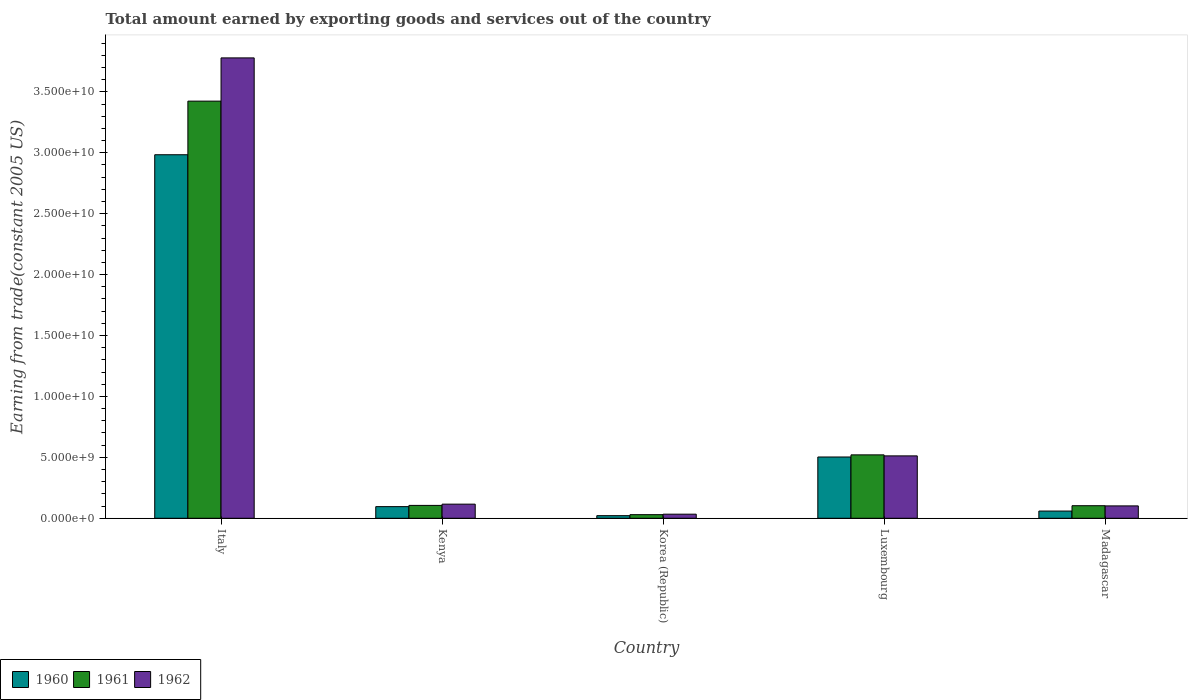How many different coloured bars are there?
Provide a succinct answer. 3. How many groups of bars are there?
Ensure brevity in your answer.  5. How many bars are there on the 3rd tick from the left?
Provide a short and direct response. 3. How many bars are there on the 4th tick from the right?
Your answer should be very brief. 3. What is the label of the 3rd group of bars from the left?
Your response must be concise. Korea (Republic). What is the total amount earned by exporting goods and services in 1962 in Kenya?
Your response must be concise. 1.16e+09. Across all countries, what is the maximum total amount earned by exporting goods and services in 1962?
Provide a succinct answer. 3.78e+1. Across all countries, what is the minimum total amount earned by exporting goods and services in 1962?
Offer a terse response. 3.35e+08. What is the total total amount earned by exporting goods and services in 1962 in the graph?
Your answer should be compact. 4.54e+1. What is the difference between the total amount earned by exporting goods and services in 1961 in Italy and that in Luxembourg?
Your response must be concise. 2.90e+1. What is the difference between the total amount earned by exporting goods and services in 1960 in Madagascar and the total amount earned by exporting goods and services in 1961 in Korea (Republic)?
Provide a succinct answer. 2.95e+08. What is the average total amount earned by exporting goods and services in 1961 per country?
Ensure brevity in your answer.  8.37e+09. What is the difference between the total amount earned by exporting goods and services of/in 1962 and total amount earned by exporting goods and services of/in 1960 in Kenya?
Keep it short and to the point. 2.04e+08. In how many countries, is the total amount earned by exporting goods and services in 1962 greater than 25000000000 US$?
Offer a very short reply. 1. What is the ratio of the total amount earned by exporting goods and services in 1962 in Italy to that in Madagascar?
Offer a very short reply. 37.22. What is the difference between the highest and the second highest total amount earned by exporting goods and services in 1962?
Give a very brief answer. 3.66e+1. What is the difference between the highest and the lowest total amount earned by exporting goods and services in 1962?
Offer a very short reply. 3.75e+1. Is the sum of the total amount earned by exporting goods and services in 1962 in Korea (Republic) and Luxembourg greater than the maximum total amount earned by exporting goods and services in 1960 across all countries?
Your response must be concise. No. What does the 1st bar from the right in Italy represents?
Your answer should be very brief. 1962. Is it the case that in every country, the sum of the total amount earned by exporting goods and services in 1960 and total amount earned by exporting goods and services in 1961 is greater than the total amount earned by exporting goods and services in 1962?
Ensure brevity in your answer.  Yes. Are all the bars in the graph horizontal?
Make the answer very short. No. How many countries are there in the graph?
Give a very brief answer. 5. Does the graph contain any zero values?
Your response must be concise. No. Where does the legend appear in the graph?
Offer a terse response. Bottom left. How many legend labels are there?
Provide a succinct answer. 3. How are the legend labels stacked?
Ensure brevity in your answer.  Horizontal. What is the title of the graph?
Give a very brief answer. Total amount earned by exporting goods and services out of the country. What is the label or title of the X-axis?
Offer a very short reply. Country. What is the label or title of the Y-axis?
Your answer should be very brief. Earning from trade(constant 2005 US). What is the Earning from trade(constant 2005 US) in 1960 in Italy?
Your answer should be compact. 2.98e+1. What is the Earning from trade(constant 2005 US) in 1961 in Italy?
Offer a very short reply. 3.42e+1. What is the Earning from trade(constant 2005 US) of 1962 in Italy?
Your answer should be very brief. 3.78e+1. What is the Earning from trade(constant 2005 US) of 1960 in Kenya?
Give a very brief answer. 9.56e+08. What is the Earning from trade(constant 2005 US) in 1961 in Kenya?
Your answer should be compact. 1.06e+09. What is the Earning from trade(constant 2005 US) in 1962 in Kenya?
Your answer should be compact. 1.16e+09. What is the Earning from trade(constant 2005 US) in 1960 in Korea (Republic)?
Your response must be concise. 2.14e+08. What is the Earning from trade(constant 2005 US) of 1961 in Korea (Republic)?
Keep it short and to the point. 2.96e+08. What is the Earning from trade(constant 2005 US) of 1962 in Korea (Republic)?
Make the answer very short. 3.35e+08. What is the Earning from trade(constant 2005 US) of 1960 in Luxembourg?
Your answer should be compact. 5.03e+09. What is the Earning from trade(constant 2005 US) in 1961 in Luxembourg?
Make the answer very short. 5.20e+09. What is the Earning from trade(constant 2005 US) of 1962 in Luxembourg?
Offer a very short reply. 5.12e+09. What is the Earning from trade(constant 2005 US) in 1960 in Madagascar?
Your answer should be compact. 5.92e+08. What is the Earning from trade(constant 2005 US) in 1961 in Madagascar?
Provide a succinct answer. 1.03e+09. What is the Earning from trade(constant 2005 US) of 1962 in Madagascar?
Provide a succinct answer. 1.02e+09. Across all countries, what is the maximum Earning from trade(constant 2005 US) of 1960?
Give a very brief answer. 2.98e+1. Across all countries, what is the maximum Earning from trade(constant 2005 US) of 1961?
Your response must be concise. 3.42e+1. Across all countries, what is the maximum Earning from trade(constant 2005 US) in 1962?
Keep it short and to the point. 3.78e+1. Across all countries, what is the minimum Earning from trade(constant 2005 US) of 1960?
Make the answer very short. 2.14e+08. Across all countries, what is the minimum Earning from trade(constant 2005 US) of 1961?
Offer a very short reply. 2.96e+08. Across all countries, what is the minimum Earning from trade(constant 2005 US) in 1962?
Offer a very short reply. 3.35e+08. What is the total Earning from trade(constant 2005 US) in 1960 in the graph?
Ensure brevity in your answer.  3.66e+1. What is the total Earning from trade(constant 2005 US) of 1961 in the graph?
Offer a terse response. 4.18e+1. What is the total Earning from trade(constant 2005 US) of 1962 in the graph?
Your response must be concise. 4.54e+1. What is the difference between the Earning from trade(constant 2005 US) of 1960 in Italy and that in Kenya?
Your answer should be very brief. 2.89e+1. What is the difference between the Earning from trade(constant 2005 US) in 1961 in Italy and that in Kenya?
Provide a short and direct response. 3.32e+1. What is the difference between the Earning from trade(constant 2005 US) in 1962 in Italy and that in Kenya?
Give a very brief answer. 3.66e+1. What is the difference between the Earning from trade(constant 2005 US) in 1960 in Italy and that in Korea (Republic)?
Your answer should be compact. 2.96e+1. What is the difference between the Earning from trade(constant 2005 US) of 1961 in Italy and that in Korea (Republic)?
Offer a very short reply. 3.39e+1. What is the difference between the Earning from trade(constant 2005 US) of 1962 in Italy and that in Korea (Republic)?
Your answer should be compact. 3.75e+1. What is the difference between the Earning from trade(constant 2005 US) of 1960 in Italy and that in Luxembourg?
Offer a very short reply. 2.48e+1. What is the difference between the Earning from trade(constant 2005 US) in 1961 in Italy and that in Luxembourg?
Your response must be concise. 2.90e+1. What is the difference between the Earning from trade(constant 2005 US) in 1962 in Italy and that in Luxembourg?
Provide a short and direct response. 3.27e+1. What is the difference between the Earning from trade(constant 2005 US) of 1960 in Italy and that in Madagascar?
Your answer should be very brief. 2.92e+1. What is the difference between the Earning from trade(constant 2005 US) of 1961 in Italy and that in Madagascar?
Offer a terse response. 3.32e+1. What is the difference between the Earning from trade(constant 2005 US) in 1962 in Italy and that in Madagascar?
Your answer should be very brief. 3.68e+1. What is the difference between the Earning from trade(constant 2005 US) in 1960 in Kenya and that in Korea (Republic)?
Give a very brief answer. 7.42e+08. What is the difference between the Earning from trade(constant 2005 US) of 1961 in Kenya and that in Korea (Republic)?
Give a very brief answer. 7.60e+08. What is the difference between the Earning from trade(constant 2005 US) in 1962 in Kenya and that in Korea (Republic)?
Your answer should be compact. 8.24e+08. What is the difference between the Earning from trade(constant 2005 US) in 1960 in Kenya and that in Luxembourg?
Provide a short and direct response. -4.07e+09. What is the difference between the Earning from trade(constant 2005 US) in 1961 in Kenya and that in Luxembourg?
Make the answer very short. -4.15e+09. What is the difference between the Earning from trade(constant 2005 US) of 1962 in Kenya and that in Luxembourg?
Offer a very short reply. -3.96e+09. What is the difference between the Earning from trade(constant 2005 US) in 1960 in Kenya and that in Madagascar?
Make the answer very short. 3.64e+08. What is the difference between the Earning from trade(constant 2005 US) in 1961 in Kenya and that in Madagascar?
Offer a terse response. 2.53e+07. What is the difference between the Earning from trade(constant 2005 US) of 1962 in Kenya and that in Madagascar?
Offer a terse response. 1.44e+08. What is the difference between the Earning from trade(constant 2005 US) of 1960 in Korea (Republic) and that in Luxembourg?
Give a very brief answer. -4.81e+09. What is the difference between the Earning from trade(constant 2005 US) of 1961 in Korea (Republic) and that in Luxembourg?
Your response must be concise. -4.91e+09. What is the difference between the Earning from trade(constant 2005 US) in 1962 in Korea (Republic) and that in Luxembourg?
Make the answer very short. -4.79e+09. What is the difference between the Earning from trade(constant 2005 US) of 1960 in Korea (Republic) and that in Madagascar?
Offer a terse response. -3.78e+08. What is the difference between the Earning from trade(constant 2005 US) in 1961 in Korea (Republic) and that in Madagascar?
Provide a short and direct response. -7.35e+08. What is the difference between the Earning from trade(constant 2005 US) in 1962 in Korea (Republic) and that in Madagascar?
Provide a short and direct response. -6.80e+08. What is the difference between the Earning from trade(constant 2005 US) of 1960 in Luxembourg and that in Madagascar?
Your response must be concise. 4.44e+09. What is the difference between the Earning from trade(constant 2005 US) of 1961 in Luxembourg and that in Madagascar?
Your answer should be very brief. 4.17e+09. What is the difference between the Earning from trade(constant 2005 US) of 1962 in Luxembourg and that in Madagascar?
Your answer should be very brief. 4.11e+09. What is the difference between the Earning from trade(constant 2005 US) of 1960 in Italy and the Earning from trade(constant 2005 US) of 1961 in Kenya?
Keep it short and to the point. 2.88e+1. What is the difference between the Earning from trade(constant 2005 US) of 1960 in Italy and the Earning from trade(constant 2005 US) of 1962 in Kenya?
Make the answer very short. 2.87e+1. What is the difference between the Earning from trade(constant 2005 US) of 1961 in Italy and the Earning from trade(constant 2005 US) of 1962 in Kenya?
Give a very brief answer. 3.31e+1. What is the difference between the Earning from trade(constant 2005 US) in 1960 in Italy and the Earning from trade(constant 2005 US) in 1961 in Korea (Republic)?
Your response must be concise. 2.95e+1. What is the difference between the Earning from trade(constant 2005 US) in 1960 in Italy and the Earning from trade(constant 2005 US) in 1962 in Korea (Republic)?
Provide a succinct answer. 2.95e+1. What is the difference between the Earning from trade(constant 2005 US) of 1961 in Italy and the Earning from trade(constant 2005 US) of 1962 in Korea (Republic)?
Make the answer very short. 3.39e+1. What is the difference between the Earning from trade(constant 2005 US) in 1960 in Italy and the Earning from trade(constant 2005 US) in 1961 in Luxembourg?
Make the answer very short. 2.46e+1. What is the difference between the Earning from trade(constant 2005 US) in 1960 in Italy and the Earning from trade(constant 2005 US) in 1962 in Luxembourg?
Offer a very short reply. 2.47e+1. What is the difference between the Earning from trade(constant 2005 US) in 1961 in Italy and the Earning from trade(constant 2005 US) in 1962 in Luxembourg?
Give a very brief answer. 2.91e+1. What is the difference between the Earning from trade(constant 2005 US) in 1960 in Italy and the Earning from trade(constant 2005 US) in 1961 in Madagascar?
Offer a very short reply. 2.88e+1. What is the difference between the Earning from trade(constant 2005 US) in 1960 in Italy and the Earning from trade(constant 2005 US) in 1962 in Madagascar?
Offer a terse response. 2.88e+1. What is the difference between the Earning from trade(constant 2005 US) in 1961 in Italy and the Earning from trade(constant 2005 US) in 1962 in Madagascar?
Make the answer very short. 3.32e+1. What is the difference between the Earning from trade(constant 2005 US) of 1960 in Kenya and the Earning from trade(constant 2005 US) of 1961 in Korea (Republic)?
Provide a short and direct response. 6.59e+08. What is the difference between the Earning from trade(constant 2005 US) in 1960 in Kenya and the Earning from trade(constant 2005 US) in 1962 in Korea (Republic)?
Provide a succinct answer. 6.21e+08. What is the difference between the Earning from trade(constant 2005 US) in 1961 in Kenya and the Earning from trade(constant 2005 US) in 1962 in Korea (Republic)?
Offer a terse response. 7.21e+08. What is the difference between the Earning from trade(constant 2005 US) in 1960 in Kenya and the Earning from trade(constant 2005 US) in 1961 in Luxembourg?
Your response must be concise. -4.25e+09. What is the difference between the Earning from trade(constant 2005 US) in 1960 in Kenya and the Earning from trade(constant 2005 US) in 1962 in Luxembourg?
Give a very brief answer. -4.17e+09. What is the difference between the Earning from trade(constant 2005 US) of 1961 in Kenya and the Earning from trade(constant 2005 US) of 1962 in Luxembourg?
Provide a short and direct response. -4.06e+09. What is the difference between the Earning from trade(constant 2005 US) in 1960 in Kenya and the Earning from trade(constant 2005 US) in 1961 in Madagascar?
Make the answer very short. -7.55e+07. What is the difference between the Earning from trade(constant 2005 US) in 1960 in Kenya and the Earning from trade(constant 2005 US) in 1962 in Madagascar?
Your answer should be very brief. -5.94e+07. What is the difference between the Earning from trade(constant 2005 US) of 1961 in Kenya and the Earning from trade(constant 2005 US) of 1962 in Madagascar?
Provide a succinct answer. 4.14e+07. What is the difference between the Earning from trade(constant 2005 US) in 1960 in Korea (Republic) and the Earning from trade(constant 2005 US) in 1961 in Luxembourg?
Keep it short and to the point. -4.99e+09. What is the difference between the Earning from trade(constant 2005 US) of 1960 in Korea (Republic) and the Earning from trade(constant 2005 US) of 1962 in Luxembourg?
Your answer should be very brief. -4.91e+09. What is the difference between the Earning from trade(constant 2005 US) in 1961 in Korea (Republic) and the Earning from trade(constant 2005 US) in 1962 in Luxembourg?
Provide a short and direct response. -4.82e+09. What is the difference between the Earning from trade(constant 2005 US) in 1960 in Korea (Republic) and the Earning from trade(constant 2005 US) in 1961 in Madagascar?
Give a very brief answer. -8.17e+08. What is the difference between the Earning from trade(constant 2005 US) in 1960 in Korea (Republic) and the Earning from trade(constant 2005 US) in 1962 in Madagascar?
Make the answer very short. -8.01e+08. What is the difference between the Earning from trade(constant 2005 US) of 1961 in Korea (Republic) and the Earning from trade(constant 2005 US) of 1962 in Madagascar?
Ensure brevity in your answer.  -7.19e+08. What is the difference between the Earning from trade(constant 2005 US) in 1960 in Luxembourg and the Earning from trade(constant 2005 US) in 1961 in Madagascar?
Make the answer very short. 4.00e+09. What is the difference between the Earning from trade(constant 2005 US) of 1960 in Luxembourg and the Earning from trade(constant 2005 US) of 1962 in Madagascar?
Your response must be concise. 4.01e+09. What is the difference between the Earning from trade(constant 2005 US) of 1961 in Luxembourg and the Earning from trade(constant 2005 US) of 1962 in Madagascar?
Offer a very short reply. 4.19e+09. What is the average Earning from trade(constant 2005 US) in 1960 per country?
Make the answer very short. 7.33e+09. What is the average Earning from trade(constant 2005 US) in 1961 per country?
Your answer should be very brief. 8.37e+09. What is the average Earning from trade(constant 2005 US) of 1962 per country?
Offer a terse response. 9.08e+09. What is the difference between the Earning from trade(constant 2005 US) of 1960 and Earning from trade(constant 2005 US) of 1961 in Italy?
Your response must be concise. -4.40e+09. What is the difference between the Earning from trade(constant 2005 US) of 1960 and Earning from trade(constant 2005 US) of 1962 in Italy?
Give a very brief answer. -7.95e+09. What is the difference between the Earning from trade(constant 2005 US) of 1961 and Earning from trade(constant 2005 US) of 1962 in Italy?
Offer a very short reply. -3.55e+09. What is the difference between the Earning from trade(constant 2005 US) of 1960 and Earning from trade(constant 2005 US) of 1961 in Kenya?
Your answer should be compact. -1.01e+08. What is the difference between the Earning from trade(constant 2005 US) of 1960 and Earning from trade(constant 2005 US) of 1962 in Kenya?
Provide a short and direct response. -2.04e+08. What is the difference between the Earning from trade(constant 2005 US) in 1961 and Earning from trade(constant 2005 US) in 1962 in Kenya?
Keep it short and to the point. -1.03e+08. What is the difference between the Earning from trade(constant 2005 US) of 1960 and Earning from trade(constant 2005 US) of 1961 in Korea (Republic)?
Give a very brief answer. -8.24e+07. What is the difference between the Earning from trade(constant 2005 US) of 1960 and Earning from trade(constant 2005 US) of 1962 in Korea (Republic)?
Give a very brief answer. -1.21e+08. What is the difference between the Earning from trade(constant 2005 US) of 1961 and Earning from trade(constant 2005 US) of 1962 in Korea (Republic)?
Offer a very short reply. -3.87e+07. What is the difference between the Earning from trade(constant 2005 US) of 1960 and Earning from trade(constant 2005 US) of 1961 in Luxembourg?
Your answer should be compact. -1.75e+08. What is the difference between the Earning from trade(constant 2005 US) of 1960 and Earning from trade(constant 2005 US) of 1962 in Luxembourg?
Your answer should be very brief. -9.22e+07. What is the difference between the Earning from trade(constant 2005 US) of 1961 and Earning from trade(constant 2005 US) of 1962 in Luxembourg?
Provide a short and direct response. 8.31e+07. What is the difference between the Earning from trade(constant 2005 US) in 1960 and Earning from trade(constant 2005 US) in 1961 in Madagascar?
Ensure brevity in your answer.  -4.40e+08. What is the difference between the Earning from trade(constant 2005 US) of 1960 and Earning from trade(constant 2005 US) of 1962 in Madagascar?
Offer a very short reply. -4.24e+08. What is the difference between the Earning from trade(constant 2005 US) of 1961 and Earning from trade(constant 2005 US) of 1962 in Madagascar?
Keep it short and to the point. 1.61e+07. What is the ratio of the Earning from trade(constant 2005 US) of 1960 in Italy to that in Kenya?
Offer a terse response. 31.22. What is the ratio of the Earning from trade(constant 2005 US) in 1961 in Italy to that in Kenya?
Keep it short and to the point. 32.41. What is the ratio of the Earning from trade(constant 2005 US) of 1962 in Italy to that in Kenya?
Offer a very short reply. 32.58. What is the ratio of the Earning from trade(constant 2005 US) of 1960 in Italy to that in Korea (Republic)?
Your answer should be compact. 139.36. What is the ratio of the Earning from trade(constant 2005 US) in 1961 in Italy to that in Korea (Republic)?
Your answer should be very brief. 115.48. What is the ratio of the Earning from trade(constant 2005 US) in 1962 in Italy to that in Korea (Republic)?
Make the answer very short. 112.72. What is the ratio of the Earning from trade(constant 2005 US) in 1960 in Italy to that in Luxembourg?
Give a very brief answer. 5.93. What is the ratio of the Earning from trade(constant 2005 US) of 1961 in Italy to that in Luxembourg?
Offer a terse response. 6.58. What is the ratio of the Earning from trade(constant 2005 US) of 1962 in Italy to that in Luxembourg?
Offer a very short reply. 7.38. What is the ratio of the Earning from trade(constant 2005 US) in 1960 in Italy to that in Madagascar?
Offer a terse response. 50.43. What is the ratio of the Earning from trade(constant 2005 US) in 1961 in Italy to that in Madagascar?
Provide a succinct answer. 33.2. What is the ratio of the Earning from trade(constant 2005 US) in 1962 in Italy to that in Madagascar?
Keep it short and to the point. 37.22. What is the ratio of the Earning from trade(constant 2005 US) in 1960 in Kenya to that in Korea (Republic)?
Give a very brief answer. 4.46. What is the ratio of the Earning from trade(constant 2005 US) of 1961 in Kenya to that in Korea (Republic)?
Offer a terse response. 3.56. What is the ratio of the Earning from trade(constant 2005 US) in 1962 in Kenya to that in Korea (Republic)?
Ensure brevity in your answer.  3.46. What is the ratio of the Earning from trade(constant 2005 US) in 1960 in Kenya to that in Luxembourg?
Offer a terse response. 0.19. What is the ratio of the Earning from trade(constant 2005 US) of 1961 in Kenya to that in Luxembourg?
Offer a terse response. 0.2. What is the ratio of the Earning from trade(constant 2005 US) in 1962 in Kenya to that in Luxembourg?
Keep it short and to the point. 0.23. What is the ratio of the Earning from trade(constant 2005 US) in 1960 in Kenya to that in Madagascar?
Provide a succinct answer. 1.62. What is the ratio of the Earning from trade(constant 2005 US) of 1961 in Kenya to that in Madagascar?
Keep it short and to the point. 1.02. What is the ratio of the Earning from trade(constant 2005 US) in 1962 in Kenya to that in Madagascar?
Ensure brevity in your answer.  1.14. What is the ratio of the Earning from trade(constant 2005 US) in 1960 in Korea (Republic) to that in Luxembourg?
Your response must be concise. 0.04. What is the ratio of the Earning from trade(constant 2005 US) in 1961 in Korea (Republic) to that in Luxembourg?
Provide a short and direct response. 0.06. What is the ratio of the Earning from trade(constant 2005 US) of 1962 in Korea (Republic) to that in Luxembourg?
Ensure brevity in your answer.  0.07. What is the ratio of the Earning from trade(constant 2005 US) in 1960 in Korea (Republic) to that in Madagascar?
Offer a terse response. 0.36. What is the ratio of the Earning from trade(constant 2005 US) of 1961 in Korea (Republic) to that in Madagascar?
Ensure brevity in your answer.  0.29. What is the ratio of the Earning from trade(constant 2005 US) in 1962 in Korea (Republic) to that in Madagascar?
Your answer should be compact. 0.33. What is the ratio of the Earning from trade(constant 2005 US) in 1960 in Luxembourg to that in Madagascar?
Offer a terse response. 8.5. What is the ratio of the Earning from trade(constant 2005 US) of 1961 in Luxembourg to that in Madagascar?
Provide a succinct answer. 5.05. What is the ratio of the Earning from trade(constant 2005 US) of 1962 in Luxembourg to that in Madagascar?
Provide a short and direct response. 5.04. What is the difference between the highest and the second highest Earning from trade(constant 2005 US) in 1960?
Make the answer very short. 2.48e+1. What is the difference between the highest and the second highest Earning from trade(constant 2005 US) of 1961?
Give a very brief answer. 2.90e+1. What is the difference between the highest and the second highest Earning from trade(constant 2005 US) in 1962?
Offer a very short reply. 3.27e+1. What is the difference between the highest and the lowest Earning from trade(constant 2005 US) in 1960?
Keep it short and to the point. 2.96e+1. What is the difference between the highest and the lowest Earning from trade(constant 2005 US) in 1961?
Your answer should be compact. 3.39e+1. What is the difference between the highest and the lowest Earning from trade(constant 2005 US) in 1962?
Offer a very short reply. 3.75e+1. 